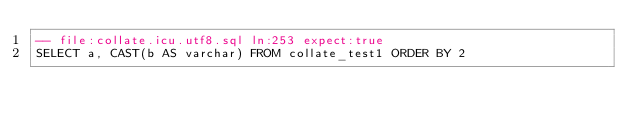<code> <loc_0><loc_0><loc_500><loc_500><_SQL_>-- file:collate.icu.utf8.sql ln:253 expect:true
SELECT a, CAST(b AS varchar) FROM collate_test1 ORDER BY 2
</code> 